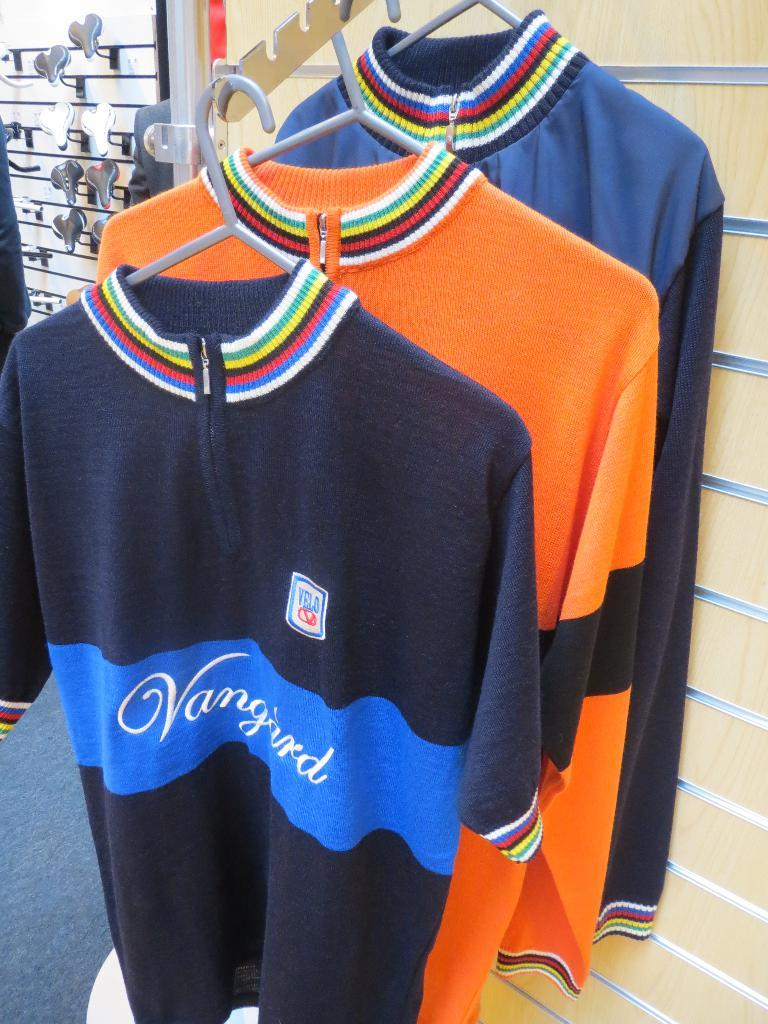<image>
Describe the image concisely. Some shirts on a display, one of them with the word Vanguard on in. 